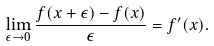Convert formula to latex. <formula><loc_0><loc_0><loc_500><loc_500>\lim _ { \epsilon \rightarrow 0 } \frac { f ( x + \epsilon ) - f ( x ) } { \epsilon } = f ^ { \prime } ( x ) .</formula> 